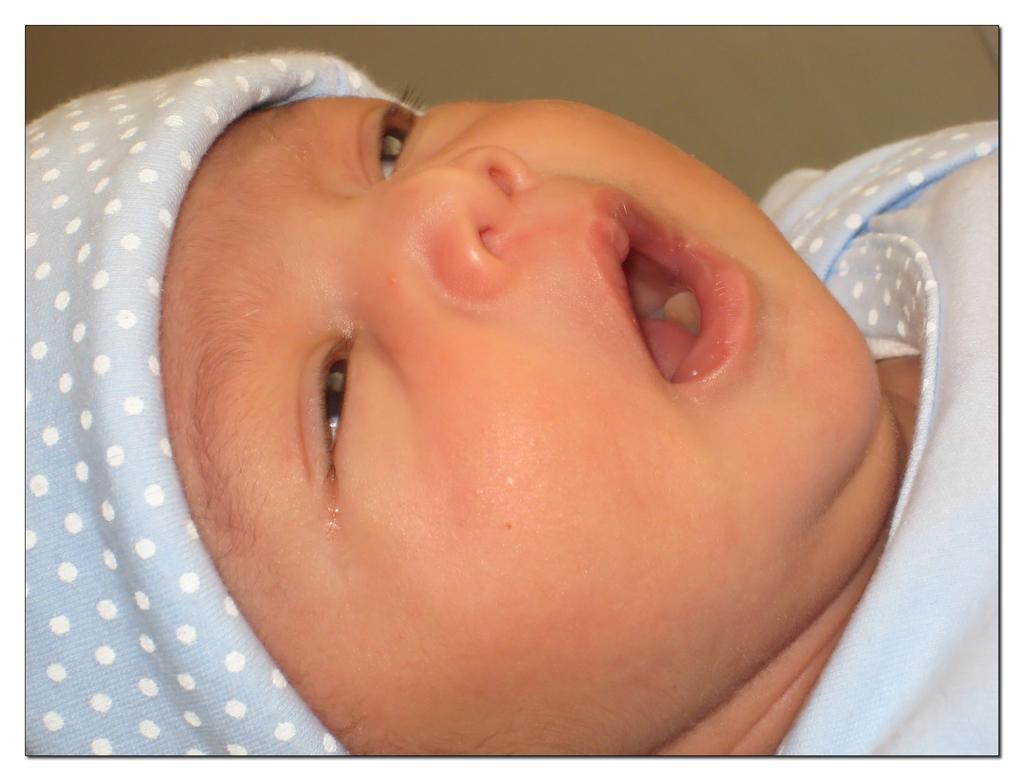Describe this image in one or two sentences. In the picture I can see a baby wearing light blue dress has opened her mouth. 